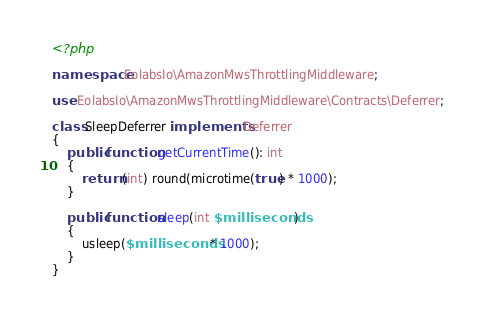<code> <loc_0><loc_0><loc_500><loc_500><_PHP_><?php

namespace EolabsIo\AmazonMwsThrottlingMiddleware;

use EolabsIo\AmazonMwsThrottlingMiddleware\Contracts\Deferrer;

class SleepDeferrer implements Deferrer
{
    public function getCurrentTime(): int
    {
        return (int) round(microtime(true) * 1000);
    }

    public function sleep(int $milliseconds)
    {
        usleep($milliseconds * 1000);
    }
}</code> 